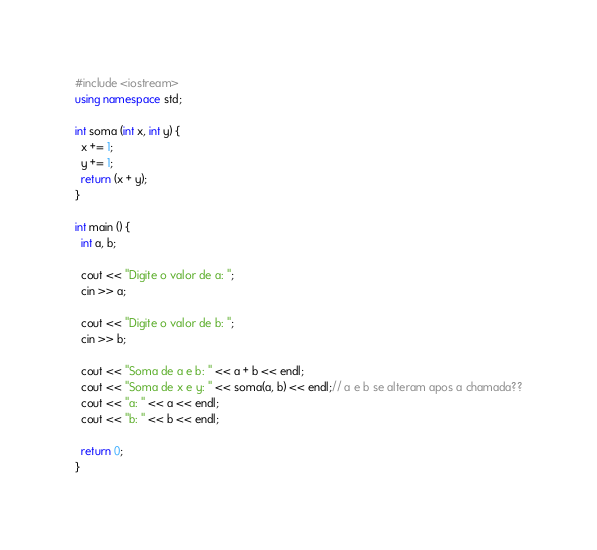<code> <loc_0><loc_0><loc_500><loc_500><_C++_>#include <iostream>
using namespace std;

int soma (int x, int y) {
  x += 1;
  y += 1;
  return (x + y);
}

int main () {
  int a, b;

  cout << "Digite o valor de a: ";
  cin >> a;

  cout << "Digite o valor de b: ";
  cin >> b;

  cout << "Soma de a e b: " << a + b << endl;
  cout << "Soma de x e y: " << soma(a, b) << endl;// a e b se alteram apos a chamada??
  cout << "a: " << a << endl;
  cout << "b: " << b << endl;

  return 0;
}
</code> 